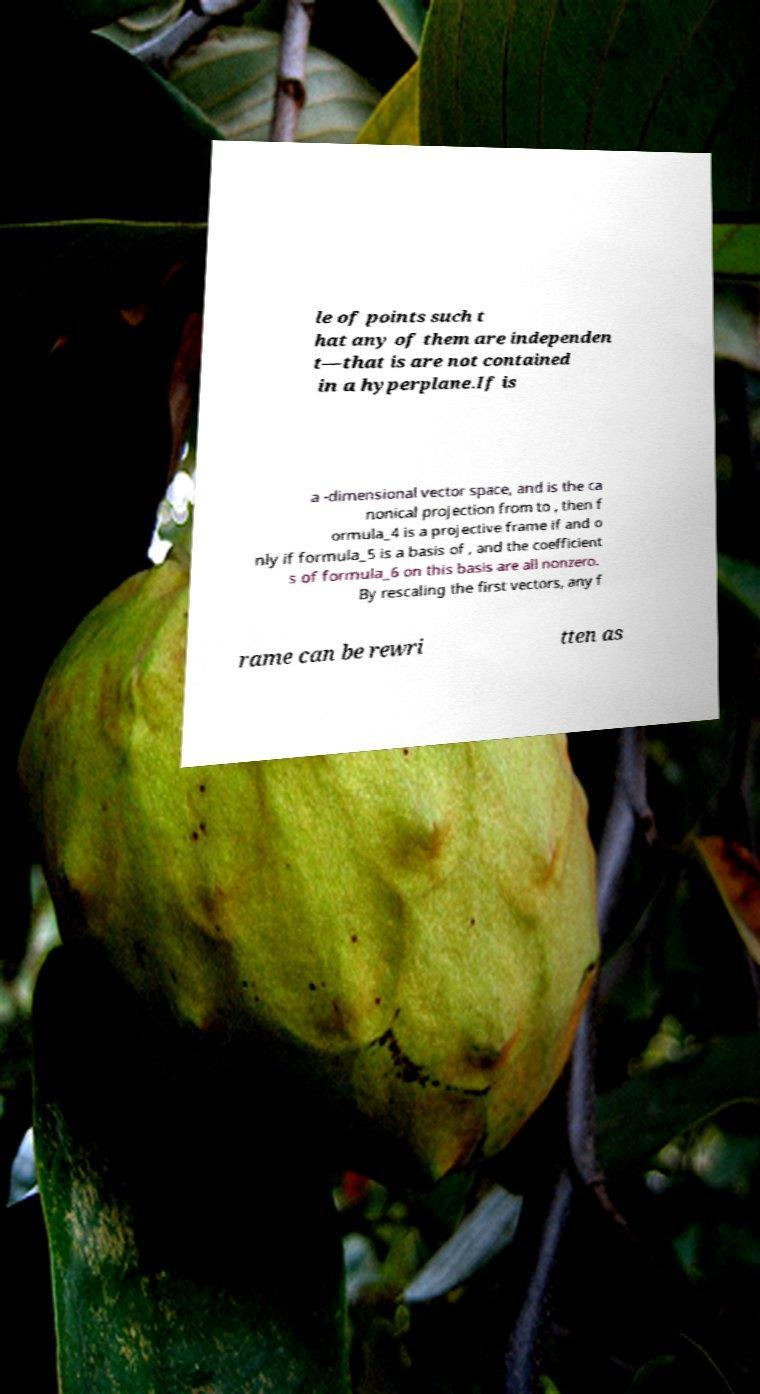Could you assist in decoding the text presented in this image and type it out clearly? le of points such t hat any of them are independen t—that is are not contained in a hyperplane.If is a -dimensional vector space, and is the ca nonical projection from to , then f ormula_4 is a projective frame if and o nly if formula_5 is a basis of , and the coefficient s of formula_6 on this basis are all nonzero. By rescaling the first vectors, any f rame can be rewri tten as 